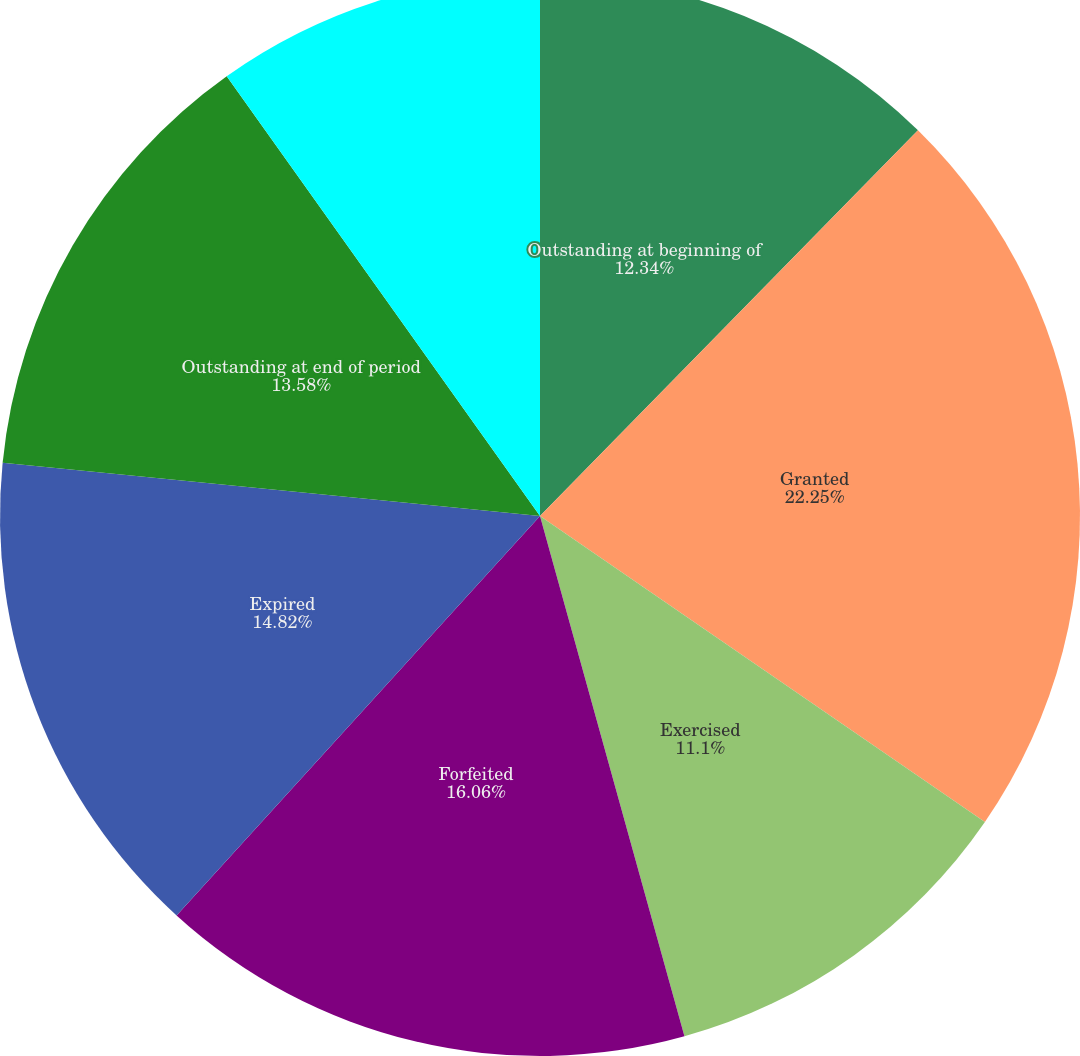Convert chart. <chart><loc_0><loc_0><loc_500><loc_500><pie_chart><fcel>Outstanding at beginning of<fcel>Granted<fcel>Exercised<fcel>Forfeited<fcel>Expired<fcel>Outstanding at end of period<fcel>Exercisable at end of period<nl><fcel>12.34%<fcel>22.25%<fcel>11.1%<fcel>16.06%<fcel>14.82%<fcel>13.58%<fcel>9.85%<nl></chart> 